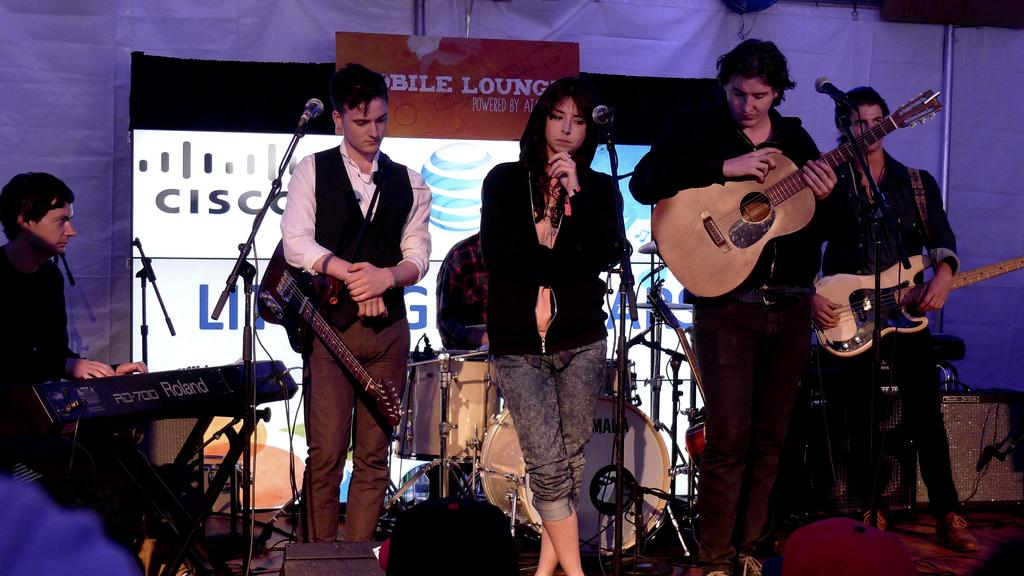How many people are in the image? There are six people in the image, four standing and two sitting. What objects are present in the image that are related to music? There is a guitar and a microphone in the image. What type of group are these people part of? This is a musical band. What type of farm animals can be seen in the image? There are no farm animals present in the image. What reward is the band receiving for their performance in the image? There is no reward visible in the image, nor is there any indication that a performance is taking place. 